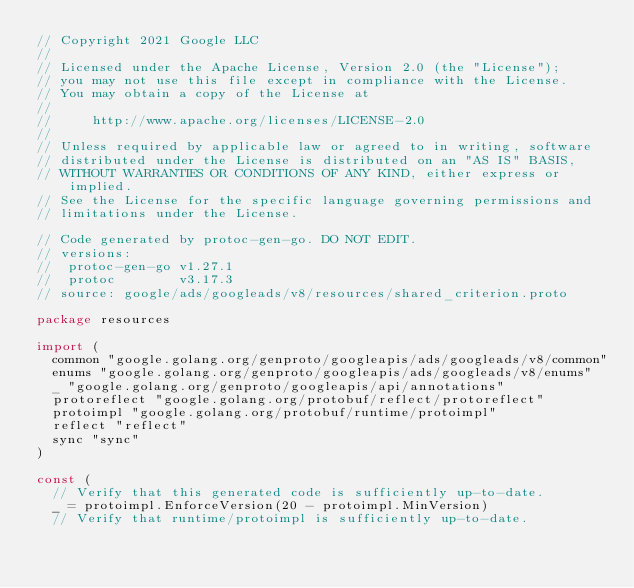<code> <loc_0><loc_0><loc_500><loc_500><_Go_>// Copyright 2021 Google LLC
//
// Licensed under the Apache License, Version 2.0 (the "License");
// you may not use this file except in compliance with the License.
// You may obtain a copy of the License at
//
//     http://www.apache.org/licenses/LICENSE-2.0
//
// Unless required by applicable law or agreed to in writing, software
// distributed under the License is distributed on an "AS IS" BASIS,
// WITHOUT WARRANTIES OR CONDITIONS OF ANY KIND, either express or implied.
// See the License for the specific language governing permissions and
// limitations under the License.

// Code generated by protoc-gen-go. DO NOT EDIT.
// versions:
// 	protoc-gen-go v1.27.1
// 	protoc        v3.17.3
// source: google/ads/googleads/v8/resources/shared_criterion.proto

package resources

import (
	common "google.golang.org/genproto/googleapis/ads/googleads/v8/common"
	enums "google.golang.org/genproto/googleapis/ads/googleads/v8/enums"
	_ "google.golang.org/genproto/googleapis/api/annotations"
	protoreflect "google.golang.org/protobuf/reflect/protoreflect"
	protoimpl "google.golang.org/protobuf/runtime/protoimpl"
	reflect "reflect"
	sync "sync"
)

const (
	// Verify that this generated code is sufficiently up-to-date.
	_ = protoimpl.EnforceVersion(20 - protoimpl.MinVersion)
	// Verify that runtime/protoimpl is sufficiently up-to-date.</code> 